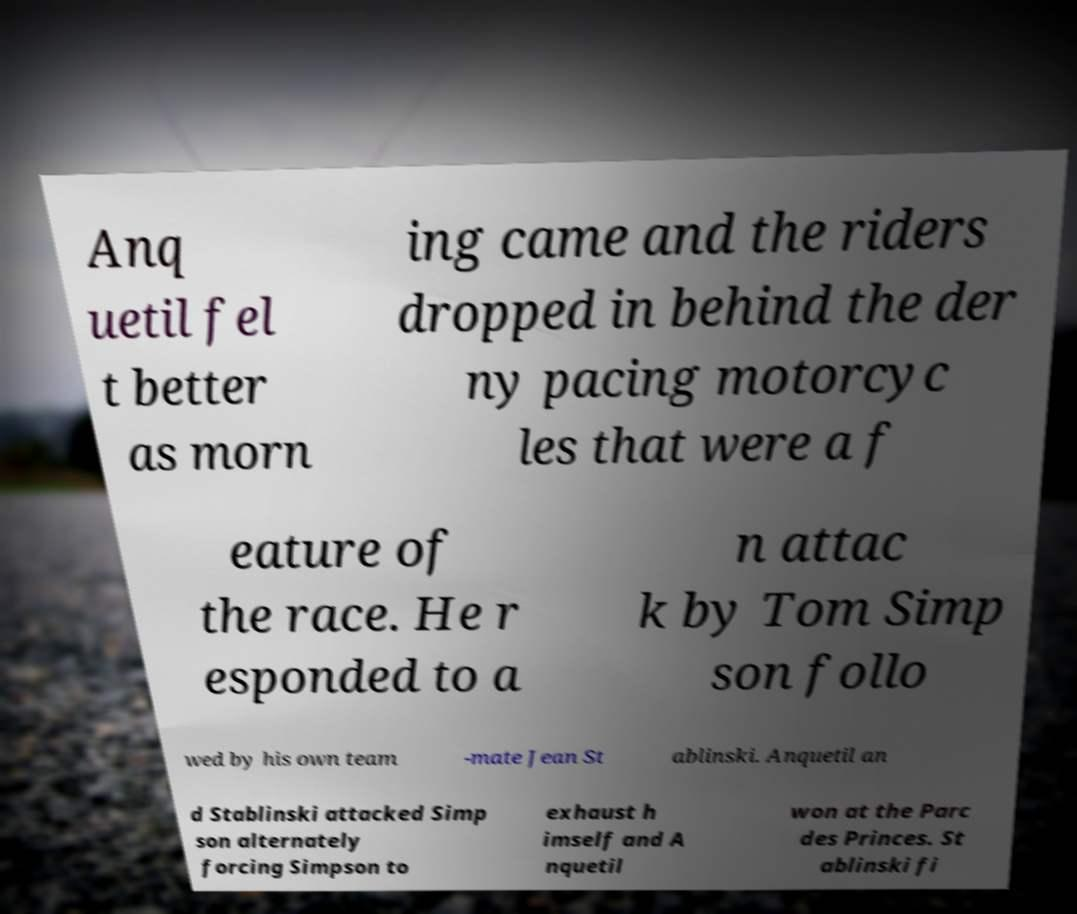Please identify and transcribe the text found in this image. Anq uetil fel t better as morn ing came and the riders dropped in behind the der ny pacing motorcyc les that were a f eature of the race. He r esponded to a n attac k by Tom Simp son follo wed by his own team -mate Jean St ablinski. Anquetil an d Stablinski attacked Simp son alternately forcing Simpson to exhaust h imself and A nquetil won at the Parc des Princes. St ablinski fi 